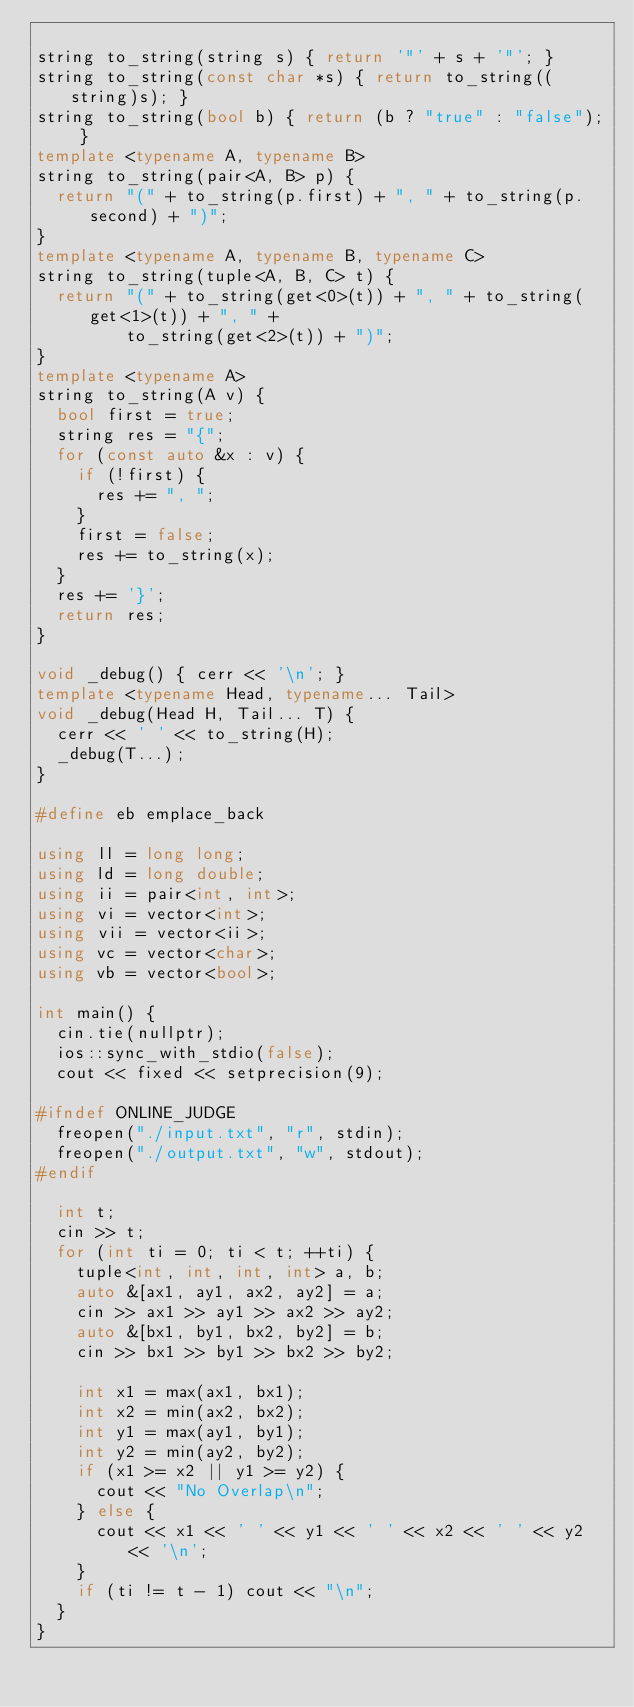Convert code to text. <code><loc_0><loc_0><loc_500><loc_500><_C++_>
string to_string(string s) { return '"' + s + '"'; }
string to_string(const char *s) { return to_string((string)s); }
string to_string(bool b) { return (b ? "true" : "false"); }
template <typename A, typename B>
string to_string(pair<A, B> p) {
  return "(" + to_string(p.first) + ", " + to_string(p.second) + ")";
}
template <typename A, typename B, typename C>
string to_string(tuple<A, B, C> t) {
  return "(" + to_string(get<0>(t)) + ", " + to_string(get<1>(t)) + ", " +
         to_string(get<2>(t)) + ")";
}
template <typename A>
string to_string(A v) {
  bool first = true;
  string res = "{";
  for (const auto &x : v) {
    if (!first) {
      res += ", ";
    }
    first = false;
    res += to_string(x);
  }
  res += '}';
  return res;
}

void _debug() { cerr << '\n'; }
template <typename Head, typename... Tail>
void _debug(Head H, Tail... T) {
  cerr << ' ' << to_string(H);
  _debug(T...);
}

#define eb emplace_back

using ll = long long;
using ld = long double;
using ii = pair<int, int>;
using vi = vector<int>;
using vii = vector<ii>;
using vc = vector<char>;
using vb = vector<bool>;

int main() {
  cin.tie(nullptr);
  ios::sync_with_stdio(false);
  cout << fixed << setprecision(9);

#ifndef ONLINE_JUDGE
  freopen("./input.txt", "r", stdin);
  freopen("./output.txt", "w", stdout);
#endif

  int t;
  cin >> t;
  for (int ti = 0; ti < t; ++ti) {
    tuple<int, int, int, int> a, b;
    auto &[ax1, ay1, ax2, ay2] = a;
    cin >> ax1 >> ay1 >> ax2 >> ay2;
    auto &[bx1, by1, bx2, by2] = b;
    cin >> bx1 >> by1 >> bx2 >> by2;

    int x1 = max(ax1, bx1);
    int x2 = min(ax2, bx2);
    int y1 = max(ay1, by1);
    int y2 = min(ay2, by2);
    if (x1 >= x2 || y1 >= y2) {
      cout << "No Overlap\n";
    } else {
      cout << x1 << ' ' << y1 << ' ' << x2 << ' ' << y2 << '\n';
    }
    if (ti != t - 1) cout << "\n";
  }
}
</code> 